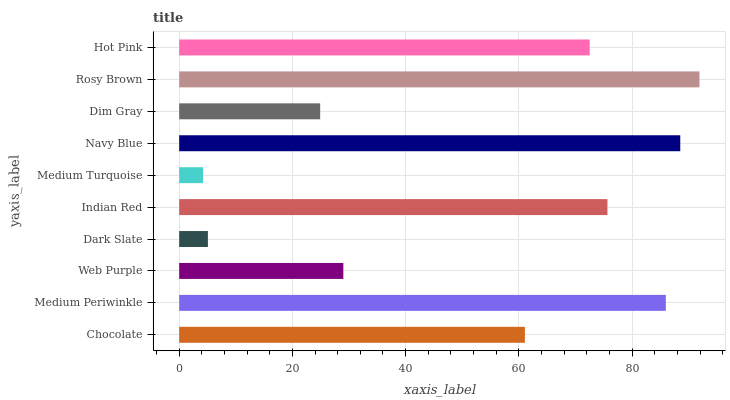Is Medium Turquoise the minimum?
Answer yes or no. Yes. Is Rosy Brown the maximum?
Answer yes or no. Yes. Is Medium Periwinkle the minimum?
Answer yes or no. No. Is Medium Periwinkle the maximum?
Answer yes or no. No. Is Medium Periwinkle greater than Chocolate?
Answer yes or no. Yes. Is Chocolate less than Medium Periwinkle?
Answer yes or no. Yes. Is Chocolate greater than Medium Periwinkle?
Answer yes or no. No. Is Medium Periwinkle less than Chocolate?
Answer yes or no. No. Is Hot Pink the high median?
Answer yes or no. Yes. Is Chocolate the low median?
Answer yes or no. Yes. Is Medium Turquoise the high median?
Answer yes or no. No. Is Rosy Brown the low median?
Answer yes or no. No. 